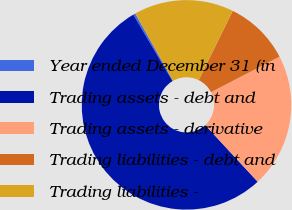Convert chart to OTSL. <chart><loc_0><loc_0><loc_500><loc_500><pie_chart><fcel>Year ended December 31 (in<fcel>Trading assets - debt and<fcel>Trading assets - derivative<fcel>Trading liabilities - debt and<fcel>Trading liabilities -<nl><fcel>0.34%<fcel>53.41%<fcel>20.73%<fcel>10.11%<fcel>15.42%<nl></chart> 